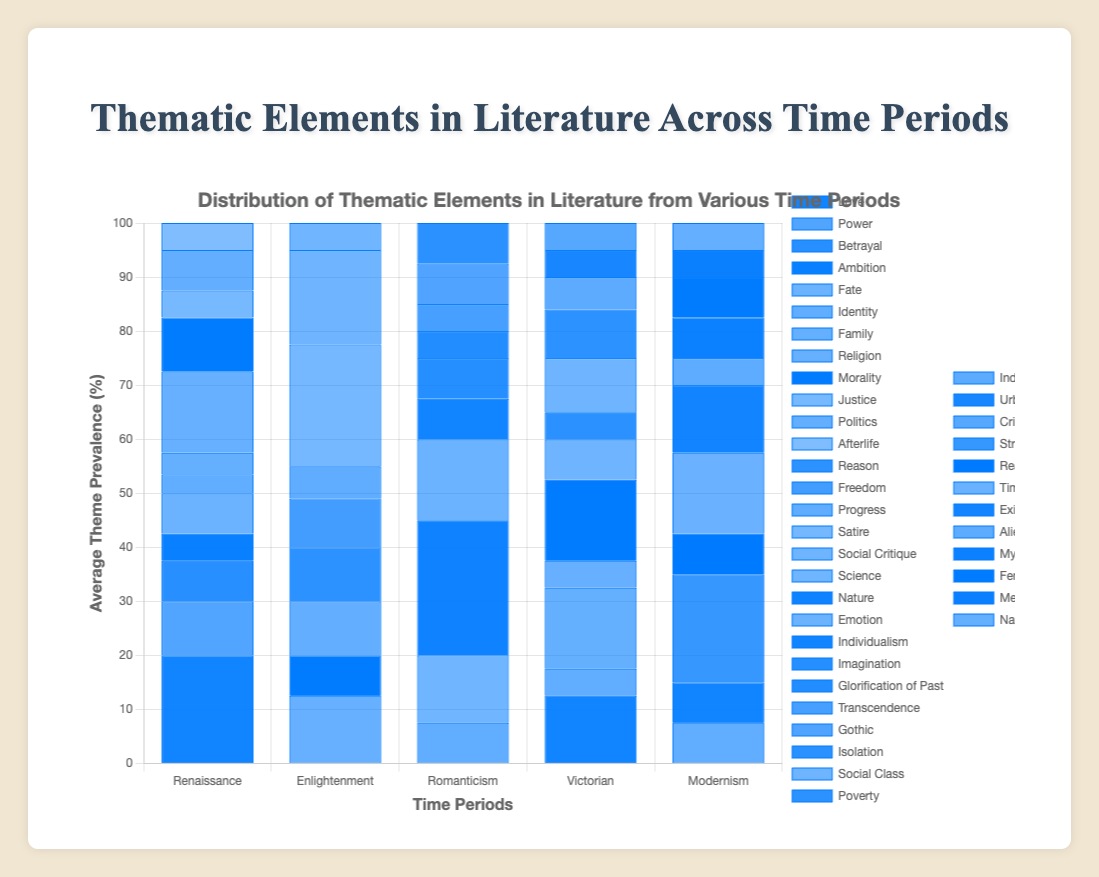What is the most prevalent theme in the literature of the Renaissance period? The bar chart shows the distribution of thematic elements across different time periods. For the Renaissance period, we can observe the highest bar, which represents the "Love" theme.
Answer: Love Which time period shows the highest average prevalence of the theme "Religion"? By looking at the heights of the bars for the theme "Religion," we can see that the Renaissance period has the highest average prevalence for this theme.
Answer: Renaissance Compare the prevalence of the theme "Satire" in the Enlightenment period with the "Gothic" theme in the Romanticism period. Which one is higher? We need to visually compare the bars representing "Satire" in the Enlightenment period and "Gothic" in the Romanticism period. The "Satire" theme has a higher bar than the "Gothic" theme.
Answer: Satire What is the average prevalence of the theme "Identity" across all time periods? To find this, we need to sum the heights of the bars for the theme "Identity" across all periods and then divide by the number of periods. The average is (7 + 15 + 15 + 15 + 10) / 5 = 12.4.
Answer: 12.4 How much more prevalent is the theme "Social Critique" in the Victorian period compared to the Modernism period? The bar for "Social Critique" in the Victorian period is higher than in the Modernism period. We calculate the difference: Victorian (15) - Modernism (0) = 15.
Answer: 15 Which theme has equal prevalence in both the Romanticism and Modernism periods? We need to look for bars of equal height for a particular theme in both the Romanticism and Modernism periods. The theme "Individualism" has the same height in both periods.
Answer: Individualism Is the theme "Power" more prevalent in the Renaissance or the Victorian period? By visually comparing the height of the bars for the theme "Power" in the Renaissance and the Victorian periods, we see that the Renaissance has a higher bar.
Answer: Renaissance What is the sum of the average prevalence of the themes "Morality" and "Fate" in the Renaissance period? Renaissance period has "Morality" as 20 and "Fate" as 15. Adding them gives 20 + 15 = 35.
Answer: 35 